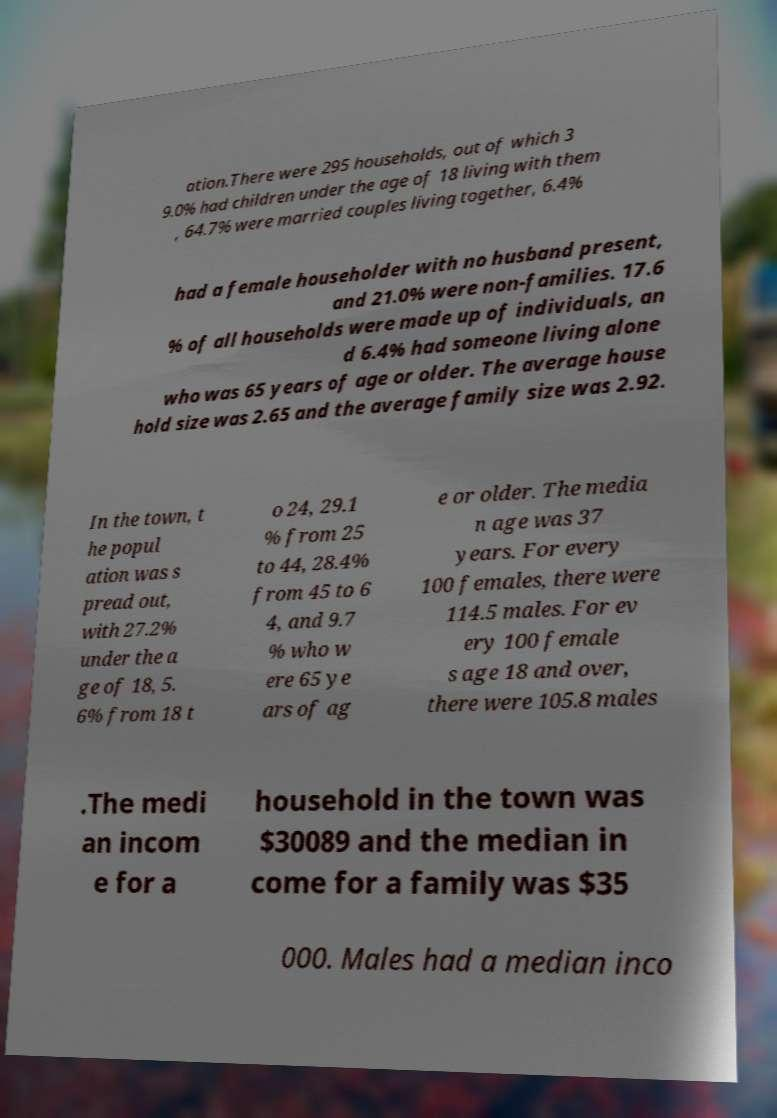There's text embedded in this image that I need extracted. Can you transcribe it verbatim? ation.There were 295 households, out of which 3 9.0% had children under the age of 18 living with them , 64.7% were married couples living together, 6.4% had a female householder with no husband present, and 21.0% were non-families. 17.6 % of all households were made up of individuals, an d 6.4% had someone living alone who was 65 years of age or older. The average house hold size was 2.65 and the average family size was 2.92. In the town, t he popul ation was s pread out, with 27.2% under the a ge of 18, 5. 6% from 18 t o 24, 29.1 % from 25 to 44, 28.4% from 45 to 6 4, and 9.7 % who w ere 65 ye ars of ag e or older. The media n age was 37 years. For every 100 females, there were 114.5 males. For ev ery 100 female s age 18 and over, there were 105.8 males .The medi an incom e for a household in the town was $30089 and the median in come for a family was $35 000. Males had a median inco 